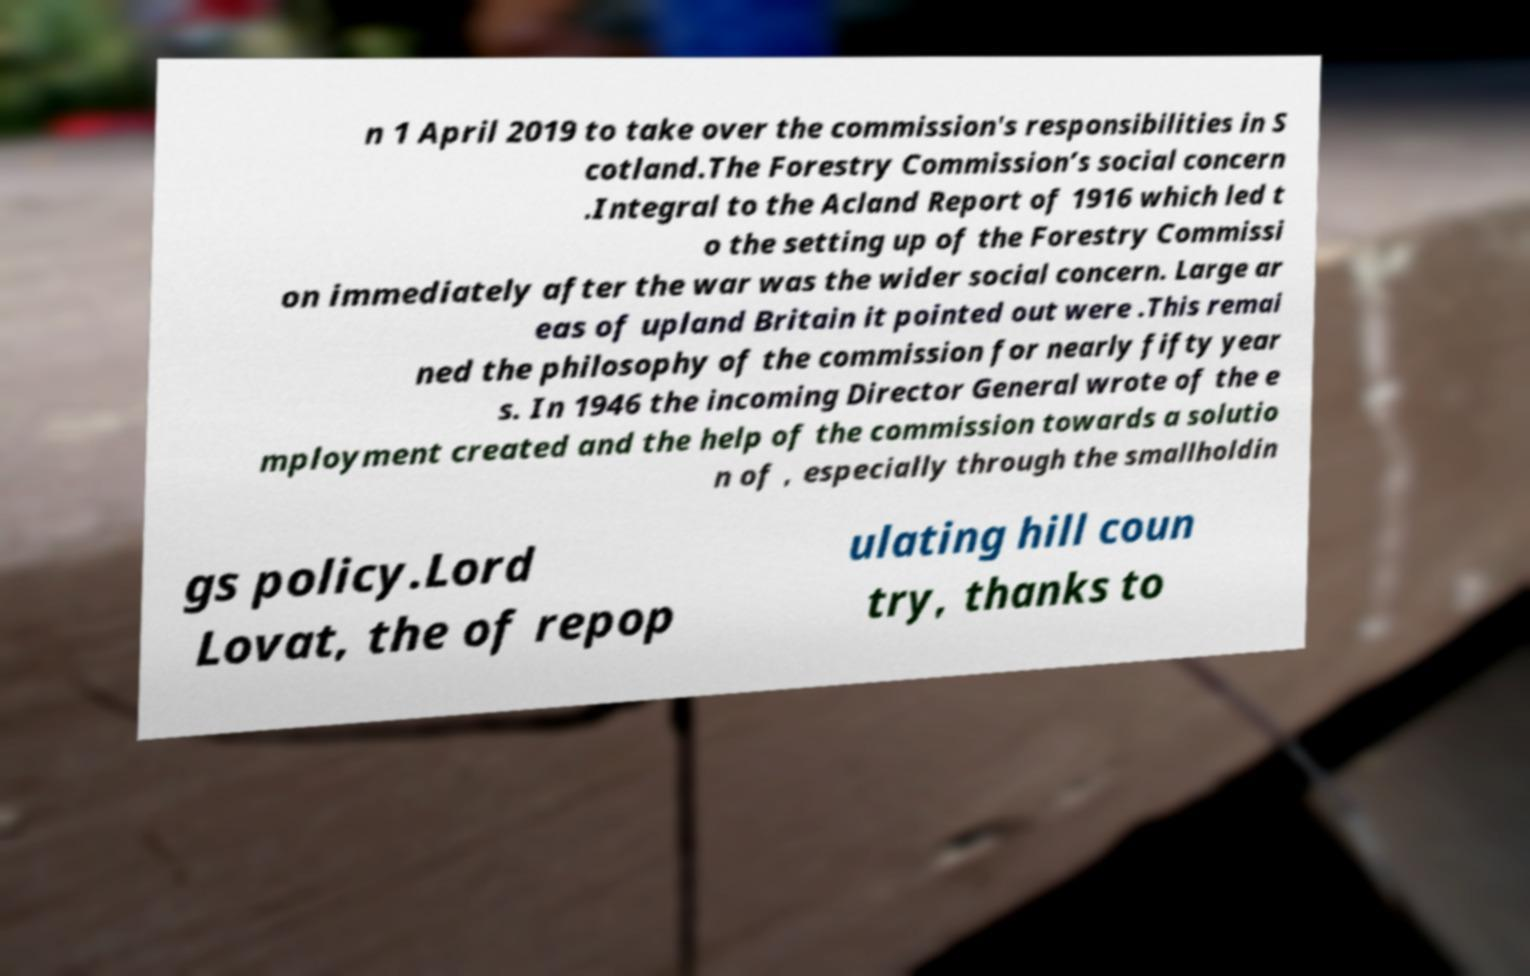What messages or text are displayed in this image? I need them in a readable, typed format. n 1 April 2019 to take over the commission's responsibilities in S cotland.The Forestry Commission’s social concern .Integral to the Acland Report of 1916 which led t o the setting up of the Forestry Commissi on immediately after the war was the wider social concern. Large ar eas of upland Britain it pointed out were .This remai ned the philosophy of the commission for nearly fifty year s. In 1946 the incoming Director General wrote of the e mployment created and the help of the commission towards a solutio n of , especially through the smallholdin gs policy.Lord Lovat, the of repop ulating hill coun try, thanks to 